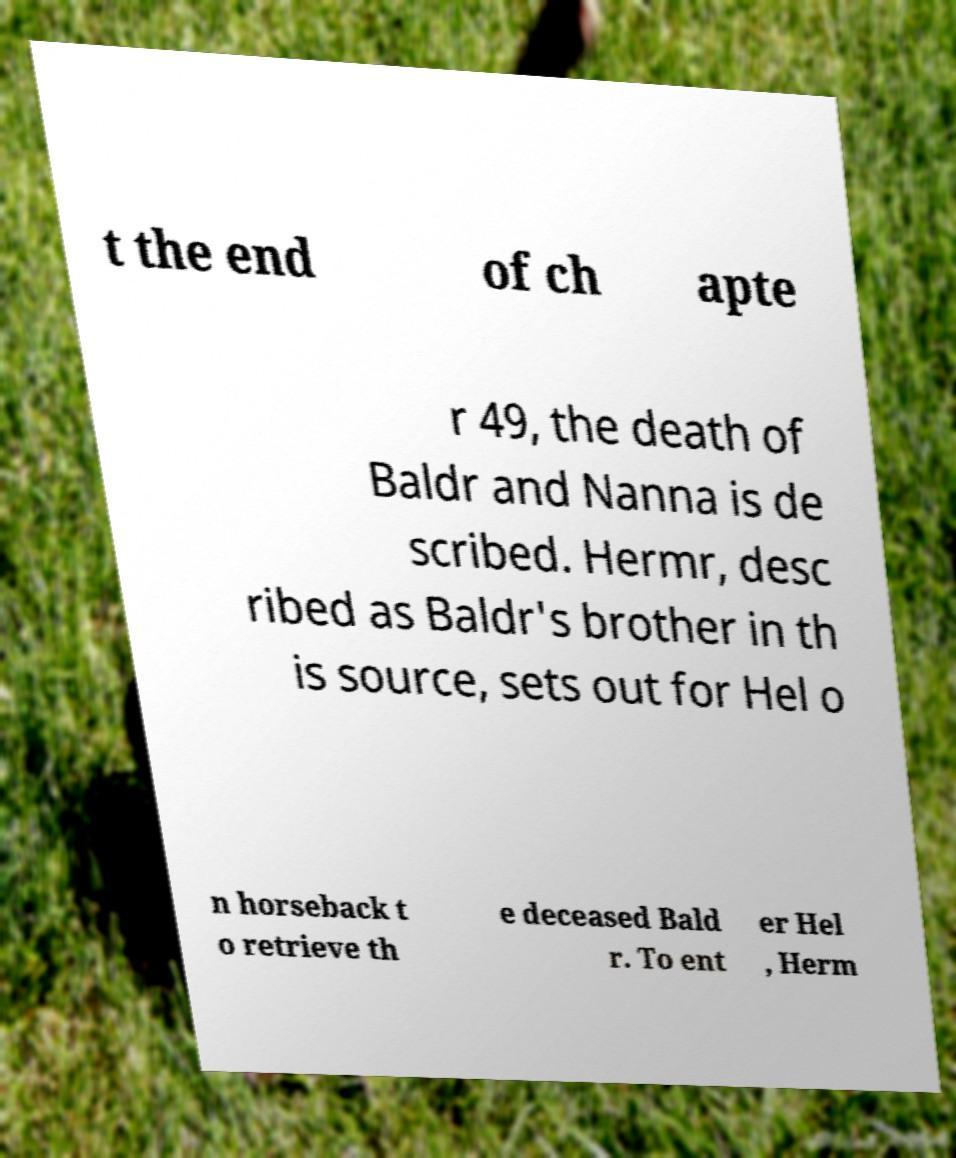Can you read and provide the text displayed in the image?This photo seems to have some interesting text. Can you extract and type it out for me? t the end of ch apte r 49, the death of Baldr and Nanna is de scribed. Hermr, desc ribed as Baldr's brother in th is source, sets out for Hel o n horseback t o retrieve th e deceased Bald r. To ent er Hel , Herm 